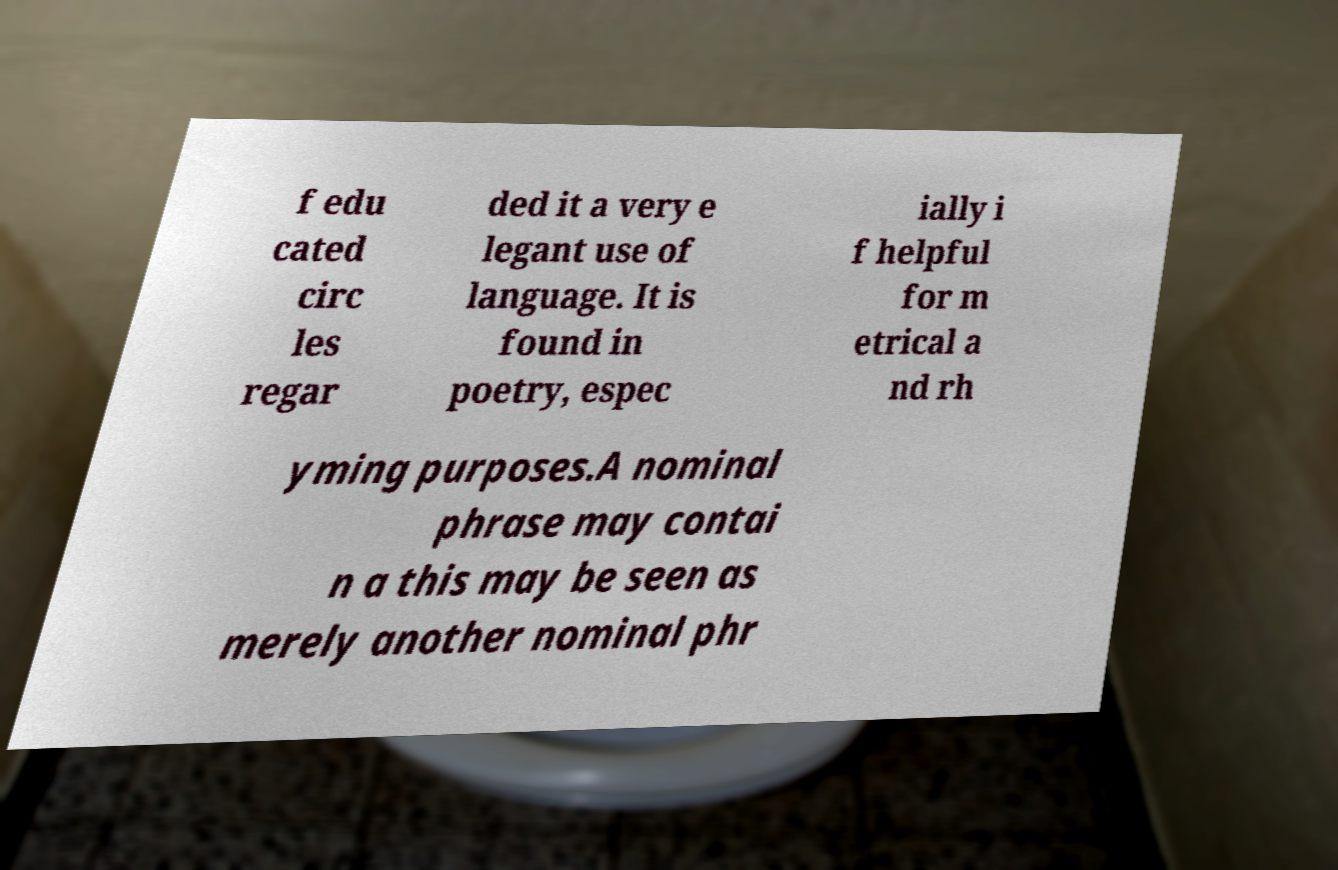Can you read and provide the text displayed in the image?This photo seems to have some interesting text. Can you extract and type it out for me? f edu cated circ les regar ded it a very e legant use of language. It is found in poetry, espec ially i f helpful for m etrical a nd rh yming purposes.A nominal phrase may contai n a this may be seen as merely another nominal phr 